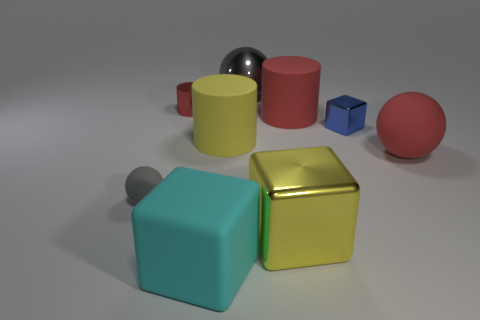Subtract all big cylinders. How many cylinders are left? 1 Subtract 3 blocks. How many blocks are left? 0 Add 1 yellow blocks. How many objects exist? 10 Subtract all red cylinders. How many cylinders are left? 1 Subtract 0 blue cylinders. How many objects are left? 9 Subtract all cubes. How many objects are left? 6 Subtract all green cylinders. Subtract all red spheres. How many cylinders are left? 3 Subtract all gray balls. How many cyan cylinders are left? 0 Subtract all small purple metal cylinders. Subtract all tiny red objects. How many objects are left? 8 Add 2 big gray metallic things. How many big gray metallic things are left? 3 